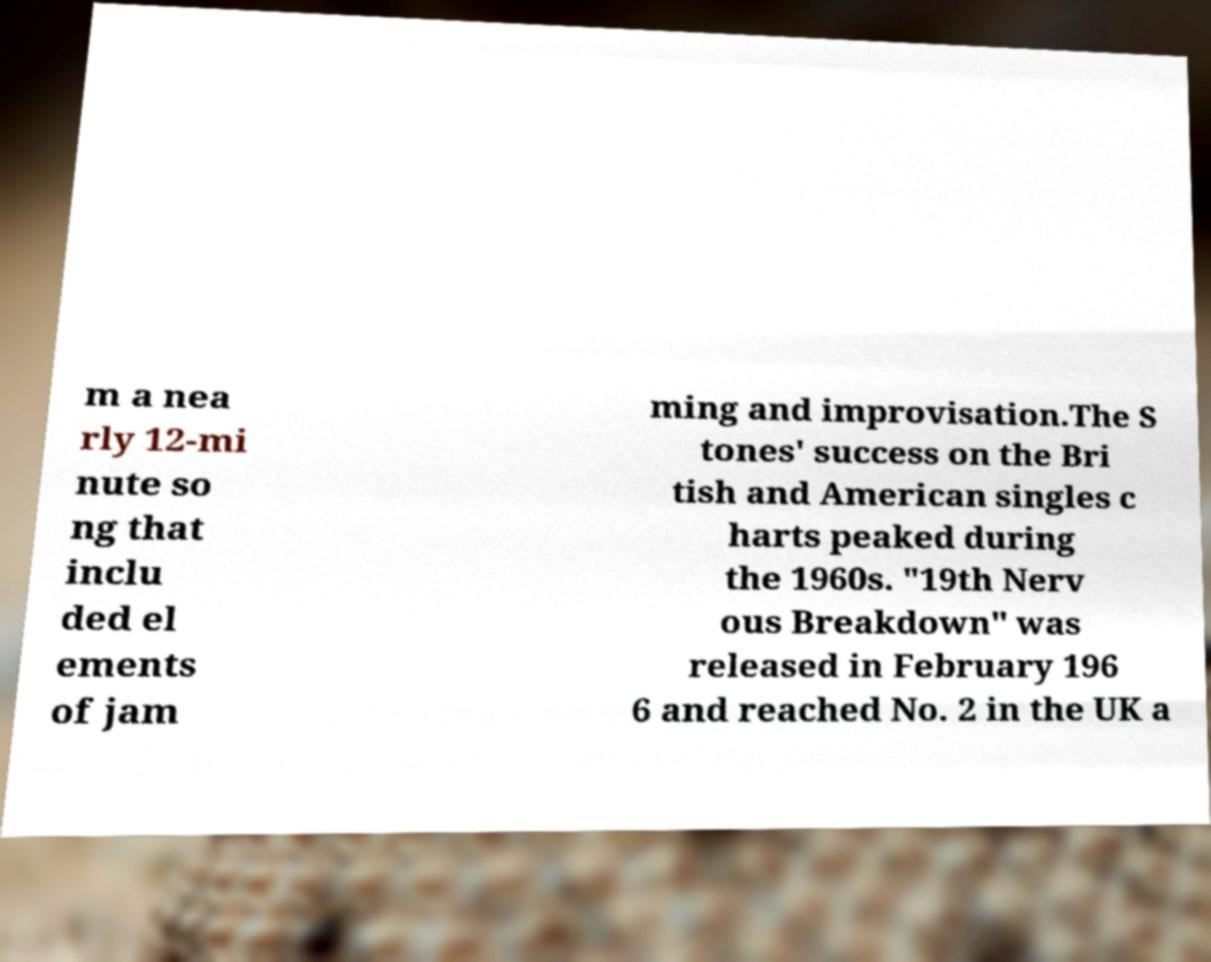I need the written content from this picture converted into text. Can you do that? m a nea rly 12-mi nute so ng that inclu ded el ements of jam ming and improvisation.The S tones' success on the Bri tish and American singles c harts peaked during the 1960s. "19th Nerv ous Breakdown" was released in February 196 6 and reached No. 2 in the UK a 